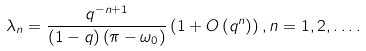<formula> <loc_0><loc_0><loc_500><loc_500>\lambda _ { n } = \frac { q ^ { - n + 1 } } { \left ( 1 - q \right ) \left ( \pi - \omega _ { 0 } \right ) } \left ( 1 + O \left ( q ^ { n } \right ) \right ) , n = 1 , 2 , \dots .</formula> 